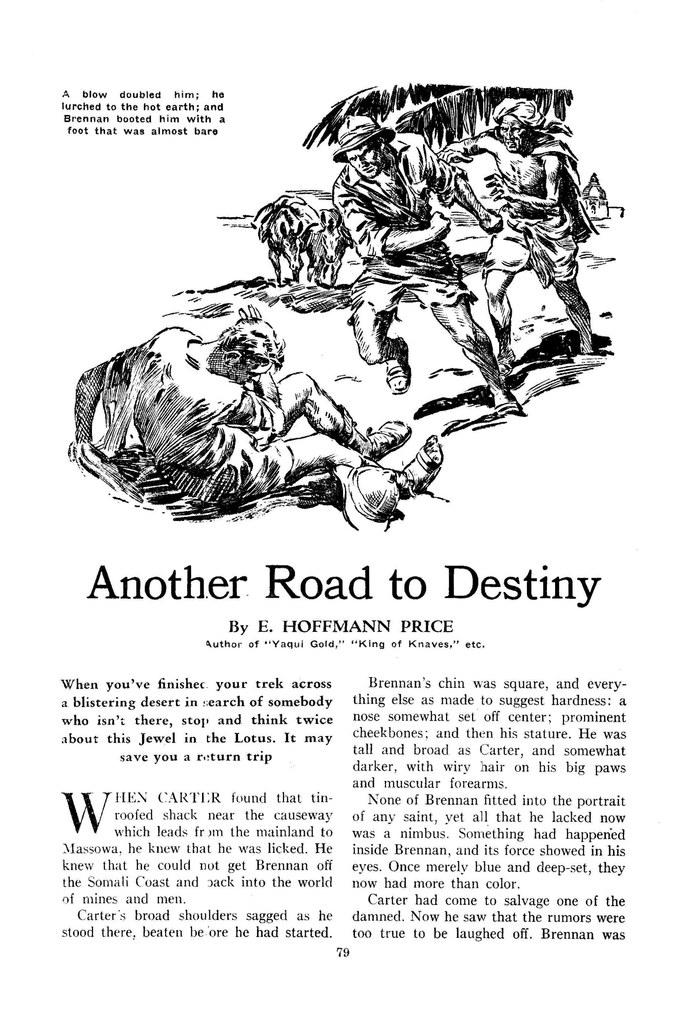What is the main object in the image? There is a printed paper in the image. What can be found on the printed paper? The printed paper contains text and a picture of men. What flavor of ice cream is being advertised in the image? There is no ice cream or advertisement present in the image; it only contains a printed paper with text and a picture of men. 